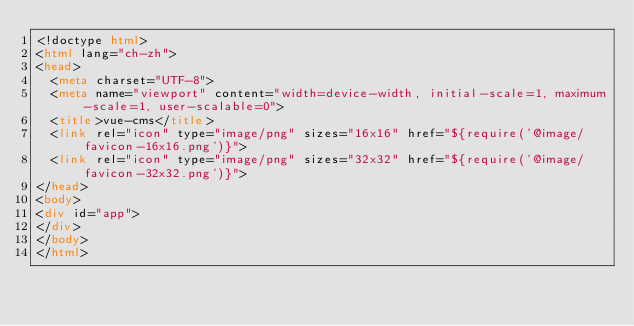<code> <loc_0><loc_0><loc_500><loc_500><_HTML_><!doctype html>
<html lang="ch-zh">
<head>
  <meta charset="UTF-8">
  <meta name="viewport" content="width=device-width, initial-scale=1, maximum-scale=1, user-scalable=0">
  <title>vue-cms</title>
  <link rel="icon" type="image/png" sizes="16x16" href="${require('@image/favicon-16x16.png')}">
  <link rel="icon" type="image/png" sizes="32x32" href="${require('@image/favicon-32x32.png')}">
</head>
<body>
<div id="app">
</div>
</body>
</html>
</code> 